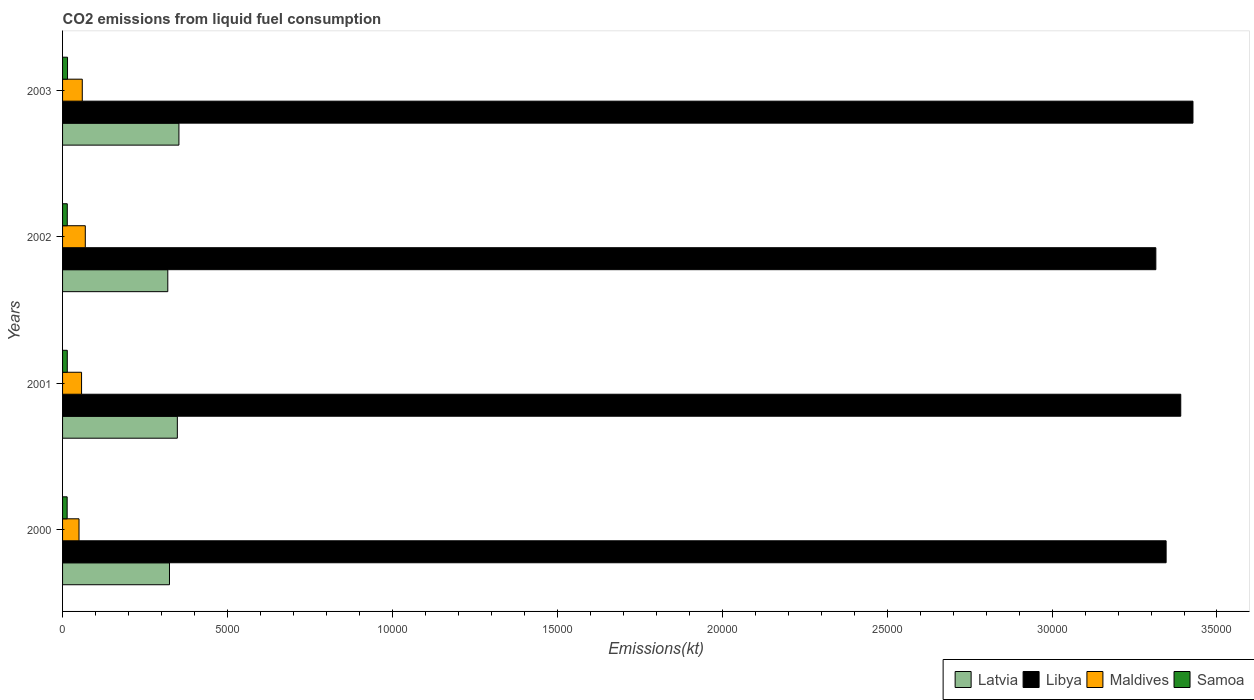How many groups of bars are there?
Ensure brevity in your answer.  4. Are the number of bars per tick equal to the number of legend labels?
Keep it short and to the point. Yes. How many bars are there on the 1st tick from the top?
Make the answer very short. 4. How many bars are there on the 3rd tick from the bottom?
Offer a very short reply. 4. What is the label of the 1st group of bars from the top?
Provide a succinct answer. 2003. In how many cases, is the number of bars for a given year not equal to the number of legend labels?
Your answer should be compact. 0. What is the amount of CO2 emitted in Maldives in 2000?
Your answer should be compact. 498.71. Across all years, what is the maximum amount of CO2 emitted in Libya?
Make the answer very short. 3.43e+04. Across all years, what is the minimum amount of CO2 emitted in Libya?
Your answer should be compact. 3.31e+04. In which year was the amount of CO2 emitted in Latvia minimum?
Provide a succinct answer. 2002. What is the total amount of CO2 emitted in Maldives in the graph?
Make the answer very short. 2361.55. What is the difference between the amount of CO2 emitted in Latvia in 2002 and that in 2003?
Your response must be concise. -337.36. What is the difference between the amount of CO2 emitted in Maldives in 2003 and the amount of CO2 emitted in Libya in 2002?
Your answer should be very brief. -3.25e+04. What is the average amount of CO2 emitted in Latvia per year?
Your answer should be compact. 3359.89. In the year 2000, what is the difference between the amount of CO2 emitted in Maldives and amount of CO2 emitted in Libya?
Your answer should be very brief. -3.30e+04. In how many years, is the amount of CO2 emitted in Latvia greater than 27000 kt?
Your response must be concise. 0. What is the ratio of the amount of CO2 emitted in Maldives in 2000 to that in 2003?
Your answer should be compact. 0.83. What is the difference between the highest and the second highest amount of CO2 emitted in Latvia?
Offer a very short reply. 47.67. What is the difference between the highest and the lowest amount of CO2 emitted in Libya?
Make the answer very short. 1125.77. Is the sum of the amount of CO2 emitted in Samoa in 2001 and 2003 greater than the maximum amount of CO2 emitted in Libya across all years?
Provide a succinct answer. No. What does the 4th bar from the top in 2002 represents?
Provide a succinct answer. Latvia. What does the 1st bar from the bottom in 2001 represents?
Offer a very short reply. Latvia. How many bars are there?
Provide a short and direct response. 16. Are all the bars in the graph horizontal?
Offer a very short reply. Yes. Where does the legend appear in the graph?
Give a very brief answer. Bottom right. How many legend labels are there?
Keep it short and to the point. 4. How are the legend labels stacked?
Offer a terse response. Horizontal. What is the title of the graph?
Ensure brevity in your answer.  CO2 emissions from liquid fuel consumption. Does "Eritrea" appear as one of the legend labels in the graph?
Give a very brief answer. No. What is the label or title of the X-axis?
Make the answer very short. Emissions(kt). What is the Emissions(kt) of Latvia in 2000?
Give a very brief answer. 3241.63. What is the Emissions(kt) in Libya in 2000?
Offer a very short reply. 3.35e+04. What is the Emissions(kt) of Maldives in 2000?
Keep it short and to the point. 498.71. What is the Emissions(kt) in Samoa in 2000?
Give a very brief answer. 139.35. What is the Emissions(kt) in Latvia in 2001?
Provide a short and direct response. 3479.98. What is the Emissions(kt) in Libya in 2001?
Keep it short and to the point. 3.39e+04. What is the Emissions(kt) of Maldives in 2001?
Your answer should be compact. 575.72. What is the Emissions(kt) in Samoa in 2001?
Offer a terse response. 143.01. What is the Emissions(kt) in Latvia in 2002?
Provide a succinct answer. 3190.29. What is the Emissions(kt) in Libya in 2002?
Provide a succinct answer. 3.31e+04. What is the Emissions(kt) of Maldives in 2002?
Provide a succinct answer. 689.4. What is the Emissions(kt) of Samoa in 2002?
Offer a very short reply. 143.01. What is the Emissions(kt) of Latvia in 2003?
Give a very brief answer. 3527.65. What is the Emissions(kt) of Libya in 2003?
Offer a very short reply. 3.43e+04. What is the Emissions(kt) of Maldives in 2003?
Your response must be concise. 597.72. What is the Emissions(kt) in Samoa in 2003?
Keep it short and to the point. 150.35. Across all years, what is the maximum Emissions(kt) of Latvia?
Keep it short and to the point. 3527.65. Across all years, what is the maximum Emissions(kt) in Libya?
Keep it short and to the point. 3.43e+04. Across all years, what is the maximum Emissions(kt) in Maldives?
Offer a terse response. 689.4. Across all years, what is the maximum Emissions(kt) in Samoa?
Provide a succinct answer. 150.35. Across all years, what is the minimum Emissions(kt) in Latvia?
Your answer should be compact. 3190.29. Across all years, what is the minimum Emissions(kt) of Libya?
Ensure brevity in your answer.  3.31e+04. Across all years, what is the minimum Emissions(kt) in Maldives?
Give a very brief answer. 498.71. Across all years, what is the minimum Emissions(kt) of Samoa?
Your answer should be compact. 139.35. What is the total Emissions(kt) of Latvia in the graph?
Give a very brief answer. 1.34e+04. What is the total Emissions(kt) in Libya in the graph?
Offer a terse response. 1.35e+05. What is the total Emissions(kt) of Maldives in the graph?
Your answer should be compact. 2361.55. What is the total Emissions(kt) in Samoa in the graph?
Ensure brevity in your answer.  575.72. What is the difference between the Emissions(kt) in Latvia in 2000 and that in 2001?
Your response must be concise. -238.35. What is the difference between the Emissions(kt) in Libya in 2000 and that in 2001?
Provide a succinct answer. -443.71. What is the difference between the Emissions(kt) in Maldives in 2000 and that in 2001?
Keep it short and to the point. -77.01. What is the difference between the Emissions(kt) of Samoa in 2000 and that in 2001?
Provide a succinct answer. -3.67. What is the difference between the Emissions(kt) of Latvia in 2000 and that in 2002?
Give a very brief answer. 51.34. What is the difference between the Emissions(kt) of Libya in 2000 and that in 2002?
Your answer should be compact. 311.69. What is the difference between the Emissions(kt) of Maldives in 2000 and that in 2002?
Provide a succinct answer. -190.68. What is the difference between the Emissions(kt) in Samoa in 2000 and that in 2002?
Your response must be concise. -3.67. What is the difference between the Emissions(kt) in Latvia in 2000 and that in 2003?
Your answer should be compact. -286.03. What is the difference between the Emissions(kt) in Libya in 2000 and that in 2003?
Offer a terse response. -814.07. What is the difference between the Emissions(kt) of Maldives in 2000 and that in 2003?
Offer a terse response. -99.01. What is the difference between the Emissions(kt) in Samoa in 2000 and that in 2003?
Your answer should be compact. -11. What is the difference between the Emissions(kt) in Latvia in 2001 and that in 2002?
Provide a short and direct response. 289.69. What is the difference between the Emissions(kt) in Libya in 2001 and that in 2002?
Keep it short and to the point. 755.4. What is the difference between the Emissions(kt) of Maldives in 2001 and that in 2002?
Your answer should be compact. -113.68. What is the difference between the Emissions(kt) in Samoa in 2001 and that in 2002?
Make the answer very short. 0. What is the difference between the Emissions(kt) of Latvia in 2001 and that in 2003?
Make the answer very short. -47.67. What is the difference between the Emissions(kt) of Libya in 2001 and that in 2003?
Offer a terse response. -370.37. What is the difference between the Emissions(kt) in Maldives in 2001 and that in 2003?
Provide a succinct answer. -22. What is the difference between the Emissions(kt) in Samoa in 2001 and that in 2003?
Keep it short and to the point. -7.33. What is the difference between the Emissions(kt) in Latvia in 2002 and that in 2003?
Offer a terse response. -337.36. What is the difference between the Emissions(kt) in Libya in 2002 and that in 2003?
Keep it short and to the point. -1125.77. What is the difference between the Emissions(kt) of Maldives in 2002 and that in 2003?
Your response must be concise. 91.67. What is the difference between the Emissions(kt) of Samoa in 2002 and that in 2003?
Your response must be concise. -7.33. What is the difference between the Emissions(kt) in Latvia in 2000 and the Emissions(kt) in Libya in 2001?
Your response must be concise. -3.07e+04. What is the difference between the Emissions(kt) in Latvia in 2000 and the Emissions(kt) in Maldives in 2001?
Ensure brevity in your answer.  2665.91. What is the difference between the Emissions(kt) of Latvia in 2000 and the Emissions(kt) of Samoa in 2001?
Your answer should be very brief. 3098.61. What is the difference between the Emissions(kt) of Libya in 2000 and the Emissions(kt) of Maldives in 2001?
Your answer should be compact. 3.29e+04. What is the difference between the Emissions(kt) of Libya in 2000 and the Emissions(kt) of Samoa in 2001?
Offer a very short reply. 3.33e+04. What is the difference between the Emissions(kt) in Maldives in 2000 and the Emissions(kt) in Samoa in 2001?
Keep it short and to the point. 355.7. What is the difference between the Emissions(kt) in Latvia in 2000 and the Emissions(kt) in Libya in 2002?
Your response must be concise. -2.99e+04. What is the difference between the Emissions(kt) in Latvia in 2000 and the Emissions(kt) in Maldives in 2002?
Give a very brief answer. 2552.23. What is the difference between the Emissions(kt) in Latvia in 2000 and the Emissions(kt) in Samoa in 2002?
Keep it short and to the point. 3098.61. What is the difference between the Emissions(kt) in Libya in 2000 and the Emissions(kt) in Maldives in 2002?
Your answer should be very brief. 3.28e+04. What is the difference between the Emissions(kt) in Libya in 2000 and the Emissions(kt) in Samoa in 2002?
Ensure brevity in your answer.  3.33e+04. What is the difference between the Emissions(kt) of Maldives in 2000 and the Emissions(kt) of Samoa in 2002?
Give a very brief answer. 355.7. What is the difference between the Emissions(kt) in Latvia in 2000 and the Emissions(kt) in Libya in 2003?
Provide a short and direct response. -3.10e+04. What is the difference between the Emissions(kt) of Latvia in 2000 and the Emissions(kt) of Maldives in 2003?
Provide a succinct answer. 2643.91. What is the difference between the Emissions(kt) of Latvia in 2000 and the Emissions(kt) of Samoa in 2003?
Give a very brief answer. 3091.28. What is the difference between the Emissions(kt) in Libya in 2000 and the Emissions(kt) in Maldives in 2003?
Your response must be concise. 3.29e+04. What is the difference between the Emissions(kt) of Libya in 2000 and the Emissions(kt) of Samoa in 2003?
Provide a short and direct response. 3.33e+04. What is the difference between the Emissions(kt) in Maldives in 2000 and the Emissions(kt) in Samoa in 2003?
Your answer should be compact. 348.37. What is the difference between the Emissions(kt) of Latvia in 2001 and the Emissions(kt) of Libya in 2002?
Provide a short and direct response. -2.97e+04. What is the difference between the Emissions(kt) in Latvia in 2001 and the Emissions(kt) in Maldives in 2002?
Offer a terse response. 2790.59. What is the difference between the Emissions(kt) of Latvia in 2001 and the Emissions(kt) of Samoa in 2002?
Your response must be concise. 3336.97. What is the difference between the Emissions(kt) in Libya in 2001 and the Emissions(kt) in Maldives in 2002?
Make the answer very short. 3.32e+04. What is the difference between the Emissions(kt) of Libya in 2001 and the Emissions(kt) of Samoa in 2002?
Give a very brief answer. 3.38e+04. What is the difference between the Emissions(kt) in Maldives in 2001 and the Emissions(kt) in Samoa in 2002?
Offer a very short reply. 432.71. What is the difference between the Emissions(kt) of Latvia in 2001 and the Emissions(kt) of Libya in 2003?
Provide a short and direct response. -3.08e+04. What is the difference between the Emissions(kt) in Latvia in 2001 and the Emissions(kt) in Maldives in 2003?
Give a very brief answer. 2882.26. What is the difference between the Emissions(kt) of Latvia in 2001 and the Emissions(kt) of Samoa in 2003?
Your answer should be very brief. 3329.64. What is the difference between the Emissions(kt) of Libya in 2001 and the Emissions(kt) of Maldives in 2003?
Provide a succinct answer. 3.33e+04. What is the difference between the Emissions(kt) in Libya in 2001 and the Emissions(kt) in Samoa in 2003?
Provide a succinct answer. 3.38e+04. What is the difference between the Emissions(kt) in Maldives in 2001 and the Emissions(kt) in Samoa in 2003?
Ensure brevity in your answer.  425.37. What is the difference between the Emissions(kt) in Latvia in 2002 and the Emissions(kt) in Libya in 2003?
Keep it short and to the point. -3.11e+04. What is the difference between the Emissions(kt) of Latvia in 2002 and the Emissions(kt) of Maldives in 2003?
Your response must be concise. 2592.57. What is the difference between the Emissions(kt) in Latvia in 2002 and the Emissions(kt) in Samoa in 2003?
Make the answer very short. 3039.94. What is the difference between the Emissions(kt) in Libya in 2002 and the Emissions(kt) in Maldives in 2003?
Make the answer very short. 3.25e+04. What is the difference between the Emissions(kt) of Libya in 2002 and the Emissions(kt) of Samoa in 2003?
Offer a terse response. 3.30e+04. What is the difference between the Emissions(kt) in Maldives in 2002 and the Emissions(kt) in Samoa in 2003?
Provide a succinct answer. 539.05. What is the average Emissions(kt) in Latvia per year?
Your response must be concise. 3359.89. What is the average Emissions(kt) in Libya per year?
Offer a terse response. 3.37e+04. What is the average Emissions(kt) in Maldives per year?
Offer a very short reply. 590.39. What is the average Emissions(kt) in Samoa per year?
Give a very brief answer. 143.93. In the year 2000, what is the difference between the Emissions(kt) of Latvia and Emissions(kt) of Libya?
Your answer should be very brief. -3.02e+04. In the year 2000, what is the difference between the Emissions(kt) in Latvia and Emissions(kt) in Maldives?
Ensure brevity in your answer.  2742.92. In the year 2000, what is the difference between the Emissions(kt) of Latvia and Emissions(kt) of Samoa?
Provide a short and direct response. 3102.28. In the year 2000, what is the difference between the Emissions(kt) in Libya and Emissions(kt) in Maldives?
Your response must be concise. 3.30e+04. In the year 2000, what is the difference between the Emissions(kt) in Libya and Emissions(kt) in Samoa?
Keep it short and to the point. 3.33e+04. In the year 2000, what is the difference between the Emissions(kt) of Maldives and Emissions(kt) of Samoa?
Make the answer very short. 359.37. In the year 2001, what is the difference between the Emissions(kt) of Latvia and Emissions(kt) of Libya?
Offer a terse response. -3.04e+04. In the year 2001, what is the difference between the Emissions(kt) in Latvia and Emissions(kt) in Maldives?
Keep it short and to the point. 2904.26. In the year 2001, what is the difference between the Emissions(kt) in Latvia and Emissions(kt) in Samoa?
Offer a terse response. 3336.97. In the year 2001, what is the difference between the Emissions(kt) in Libya and Emissions(kt) in Maldives?
Give a very brief answer. 3.33e+04. In the year 2001, what is the difference between the Emissions(kt) of Libya and Emissions(kt) of Samoa?
Your answer should be compact. 3.38e+04. In the year 2001, what is the difference between the Emissions(kt) of Maldives and Emissions(kt) of Samoa?
Ensure brevity in your answer.  432.71. In the year 2002, what is the difference between the Emissions(kt) in Latvia and Emissions(kt) in Libya?
Ensure brevity in your answer.  -3.00e+04. In the year 2002, what is the difference between the Emissions(kt) of Latvia and Emissions(kt) of Maldives?
Ensure brevity in your answer.  2500.89. In the year 2002, what is the difference between the Emissions(kt) of Latvia and Emissions(kt) of Samoa?
Your answer should be compact. 3047.28. In the year 2002, what is the difference between the Emissions(kt) of Libya and Emissions(kt) of Maldives?
Provide a short and direct response. 3.25e+04. In the year 2002, what is the difference between the Emissions(kt) of Libya and Emissions(kt) of Samoa?
Offer a very short reply. 3.30e+04. In the year 2002, what is the difference between the Emissions(kt) in Maldives and Emissions(kt) in Samoa?
Make the answer very short. 546.38. In the year 2003, what is the difference between the Emissions(kt) in Latvia and Emissions(kt) in Libya?
Offer a very short reply. -3.07e+04. In the year 2003, what is the difference between the Emissions(kt) of Latvia and Emissions(kt) of Maldives?
Offer a very short reply. 2929.93. In the year 2003, what is the difference between the Emissions(kt) in Latvia and Emissions(kt) in Samoa?
Your answer should be very brief. 3377.31. In the year 2003, what is the difference between the Emissions(kt) of Libya and Emissions(kt) of Maldives?
Provide a succinct answer. 3.37e+04. In the year 2003, what is the difference between the Emissions(kt) in Libya and Emissions(kt) in Samoa?
Give a very brief answer. 3.41e+04. In the year 2003, what is the difference between the Emissions(kt) in Maldives and Emissions(kt) in Samoa?
Your response must be concise. 447.37. What is the ratio of the Emissions(kt) of Latvia in 2000 to that in 2001?
Your response must be concise. 0.93. What is the ratio of the Emissions(kt) of Libya in 2000 to that in 2001?
Offer a very short reply. 0.99. What is the ratio of the Emissions(kt) in Maldives in 2000 to that in 2001?
Offer a terse response. 0.87. What is the ratio of the Emissions(kt) of Samoa in 2000 to that in 2001?
Offer a very short reply. 0.97. What is the ratio of the Emissions(kt) of Latvia in 2000 to that in 2002?
Provide a succinct answer. 1.02. What is the ratio of the Emissions(kt) of Libya in 2000 to that in 2002?
Provide a succinct answer. 1.01. What is the ratio of the Emissions(kt) of Maldives in 2000 to that in 2002?
Provide a succinct answer. 0.72. What is the ratio of the Emissions(kt) in Samoa in 2000 to that in 2002?
Your response must be concise. 0.97. What is the ratio of the Emissions(kt) in Latvia in 2000 to that in 2003?
Provide a short and direct response. 0.92. What is the ratio of the Emissions(kt) of Libya in 2000 to that in 2003?
Provide a short and direct response. 0.98. What is the ratio of the Emissions(kt) of Maldives in 2000 to that in 2003?
Ensure brevity in your answer.  0.83. What is the ratio of the Emissions(kt) in Samoa in 2000 to that in 2003?
Ensure brevity in your answer.  0.93. What is the ratio of the Emissions(kt) of Latvia in 2001 to that in 2002?
Keep it short and to the point. 1.09. What is the ratio of the Emissions(kt) of Libya in 2001 to that in 2002?
Your answer should be very brief. 1.02. What is the ratio of the Emissions(kt) of Maldives in 2001 to that in 2002?
Your answer should be compact. 0.84. What is the ratio of the Emissions(kt) of Latvia in 2001 to that in 2003?
Offer a terse response. 0.99. What is the ratio of the Emissions(kt) of Maldives in 2001 to that in 2003?
Give a very brief answer. 0.96. What is the ratio of the Emissions(kt) of Samoa in 2001 to that in 2003?
Provide a succinct answer. 0.95. What is the ratio of the Emissions(kt) of Latvia in 2002 to that in 2003?
Your response must be concise. 0.9. What is the ratio of the Emissions(kt) in Libya in 2002 to that in 2003?
Give a very brief answer. 0.97. What is the ratio of the Emissions(kt) of Maldives in 2002 to that in 2003?
Ensure brevity in your answer.  1.15. What is the ratio of the Emissions(kt) of Samoa in 2002 to that in 2003?
Ensure brevity in your answer.  0.95. What is the difference between the highest and the second highest Emissions(kt) of Latvia?
Keep it short and to the point. 47.67. What is the difference between the highest and the second highest Emissions(kt) in Libya?
Ensure brevity in your answer.  370.37. What is the difference between the highest and the second highest Emissions(kt) in Maldives?
Provide a succinct answer. 91.67. What is the difference between the highest and the second highest Emissions(kt) in Samoa?
Offer a very short reply. 7.33. What is the difference between the highest and the lowest Emissions(kt) in Latvia?
Make the answer very short. 337.36. What is the difference between the highest and the lowest Emissions(kt) of Libya?
Give a very brief answer. 1125.77. What is the difference between the highest and the lowest Emissions(kt) of Maldives?
Keep it short and to the point. 190.68. What is the difference between the highest and the lowest Emissions(kt) in Samoa?
Keep it short and to the point. 11. 